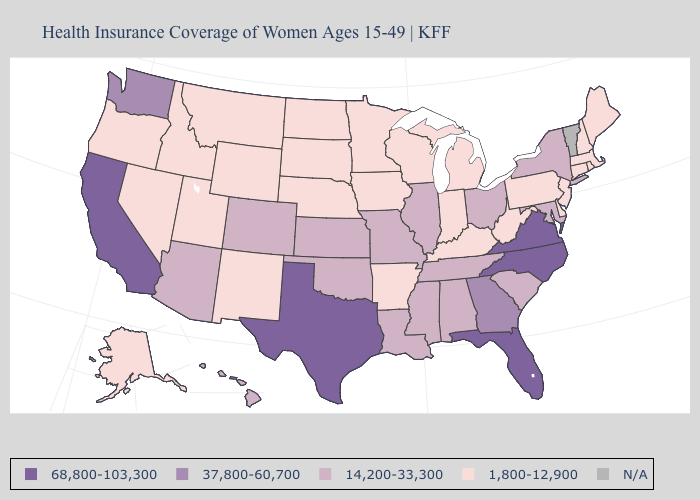Among the states that border Virginia , does North Carolina have the highest value?
Short answer required. Yes. Name the states that have a value in the range N/A?
Quick response, please. Vermont. What is the highest value in the USA?
Keep it brief. 68,800-103,300. Does the first symbol in the legend represent the smallest category?
Short answer required. No. What is the lowest value in states that border Wyoming?
Give a very brief answer. 1,800-12,900. Name the states that have a value in the range 14,200-33,300?
Give a very brief answer. Alabama, Arizona, Colorado, Hawaii, Illinois, Kansas, Louisiana, Maryland, Mississippi, Missouri, New York, Ohio, Oklahoma, South Carolina, Tennessee. Does the map have missing data?
Keep it brief. Yes. Name the states that have a value in the range N/A?
Be succinct. Vermont. Among the states that border Missouri , does Illinois have the highest value?
Short answer required. Yes. Among the states that border Kentucky , which have the highest value?
Answer briefly. Virginia. Which states have the lowest value in the West?
Quick response, please. Alaska, Idaho, Montana, Nevada, New Mexico, Oregon, Utah, Wyoming. Does Wisconsin have the lowest value in the USA?
Answer briefly. Yes. Name the states that have a value in the range 14,200-33,300?
Short answer required. Alabama, Arizona, Colorado, Hawaii, Illinois, Kansas, Louisiana, Maryland, Mississippi, Missouri, New York, Ohio, Oklahoma, South Carolina, Tennessee. What is the value of Utah?
Keep it brief. 1,800-12,900. Does the map have missing data?
Short answer required. Yes. 